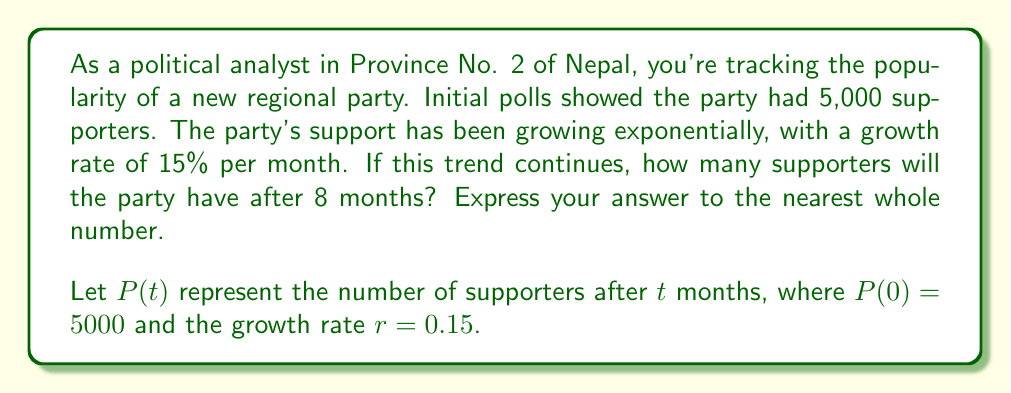Solve this math problem. To solve this problem, we'll use the exponential growth function:

$$P(t) = P_0(1 + r)^t$$

Where:
$P(t)$ is the number of supporters after $t$ months
$P_0$ is the initial number of supporters
$r$ is the growth rate (as a decimal)
$t$ is the time in months

Given:
$P_0 = 5000$
$r = 0.15$
$t = 8$

Let's substitute these values into the exponential growth function:

$$P(8) = 5000(1 + 0.15)^8$$

Now, let's calculate step-by-step:

1) First, calculate $(1 + 0.15)$:
   $1 + 0.15 = 1.15$

2) Now, we need to calculate $1.15^8$:
   $1.15^8 \approx 3.0590$

3) Finally, multiply this by the initial number of supporters:
   $5000 * 3.0590 \approx 15,295$

4) Rounding to the nearest whole number:
   $15,295 \approx 15,295$
Answer: After 8 months, the party will have approximately 15,295 supporters. 